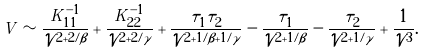<formula> <loc_0><loc_0><loc_500><loc_500>V \sim \frac { K ^ { - 1 } _ { 1 1 } } { \mathcal { V } ^ { 2 + 2 / \beta } } + \frac { K ^ { - 1 } _ { 2 2 } } { \mathcal { V } ^ { 2 + 2 / \gamma } } + \frac { \tau _ { 1 } \tau _ { 2 } } { \mathcal { V } ^ { 2 + 1 / \beta + 1 / \gamma } } - \frac { \tau _ { 1 } } { \mathcal { V } ^ { 2 + 1 / \beta } } - \frac { \tau _ { 2 } } { \mathcal { V } ^ { 2 + 1 / \gamma } } + \frac { 1 } { \mathcal { V } ^ { 3 } } .</formula> 